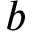Convert formula to latex. <formula><loc_0><loc_0><loc_500><loc_500>b</formula> 